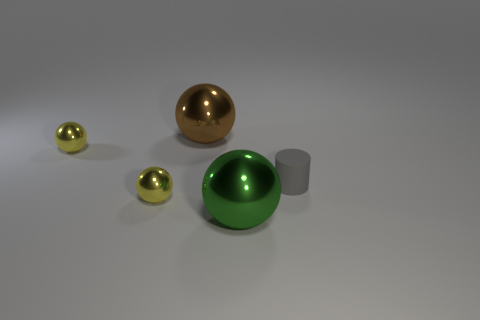Is there anything else that has the same material as the tiny cylinder?
Offer a very short reply. No. How many objects are either big green metal balls or large brown rubber blocks?
Make the answer very short. 1. Does the brown metallic object have the same size as the yellow shiny ball in front of the gray rubber cylinder?
Offer a very short reply. No. How big is the ball that is behind the small ball that is on the left side of the yellow shiny object that is in front of the gray cylinder?
Give a very brief answer. Large. Is there a yellow metal ball?
Your response must be concise. Yes. What number of objects are big metallic objects right of the large brown thing or large metallic balls in front of the small cylinder?
Offer a very short reply. 1. There is a ball right of the brown shiny thing; how many large balls are to the left of it?
Your answer should be compact. 1. There is a big sphere that is the same material as the green object; what color is it?
Make the answer very short. Brown. Is there a red rubber cylinder of the same size as the matte thing?
Give a very brief answer. No. There is a green metallic thing that is the same size as the brown ball; what shape is it?
Ensure brevity in your answer.  Sphere. 